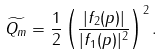<formula> <loc_0><loc_0><loc_500><loc_500>\widetilde { Q _ { m } } = \frac { 1 } { 2 } \left ( \frac { | f _ { 2 } ( p ) | } { | f _ { 1 } ( p ) | ^ { 2 } } \right ) ^ { 2 } .</formula> 